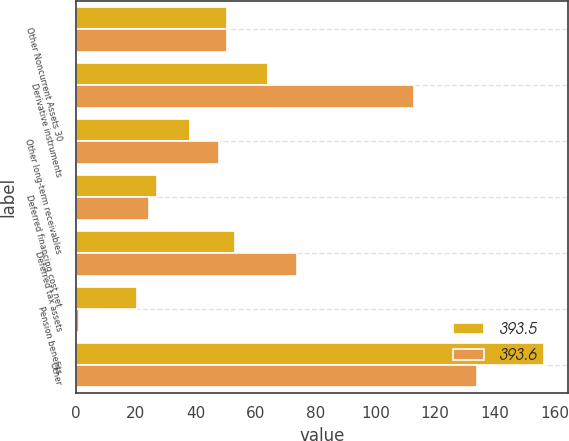Convert chart to OTSL. <chart><loc_0><loc_0><loc_500><loc_500><stacked_bar_chart><ecel><fcel>Other Noncurrent Assets 30<fcel>Derivative instruments<fcel>Other long-term receivables<fcel>Deferred financing cost net<fcel>Deferred tax assets<fcel>Pension benefits<fcel>Other<nl><fcel>393.5<fcel>50.45<fcel>64.1<fcel>38.2<fcel>27<fcel>53.1<fcel>20.5<fcel>156.5<nl><fcel>393.6<fcel>50.45<fcel>112.9<fcel>47.8<fcel>24.3<fcel>73.7<fcel>0.9<fcel>134<nl></chart> 